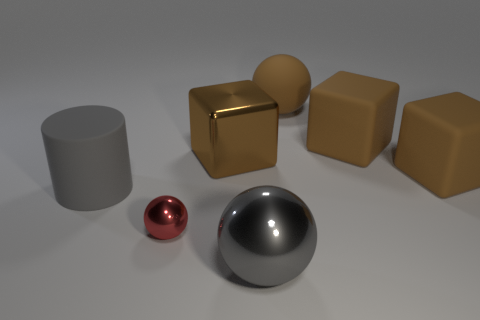Add 3 yellow matte cylinders. How many objects exist? 10 Subtract all cylinders. How many objects are left? 6 Add 4 brown shiny blocks. How many brown shiny blocks exist? 5 Subtract 0 red blocks. How many objects are left? 7 Subtract all large metal objects. Subtract all red matte spheres. How many objects are left? 5 Add 7 cylinders. How many cylinders are left? 8 